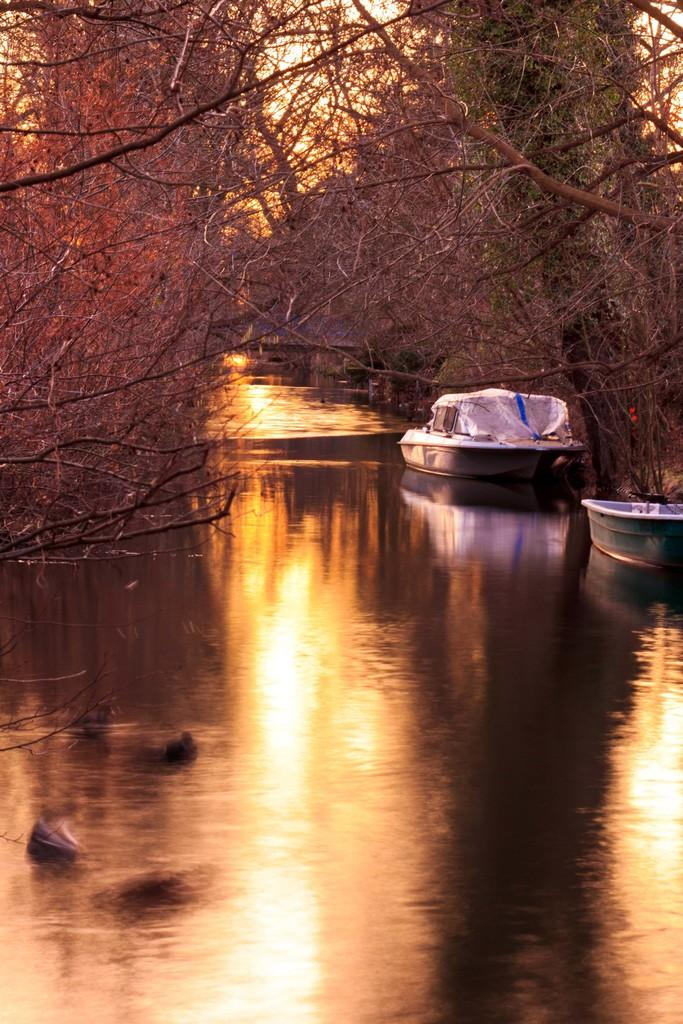What is the main feature of the image? The main feature of the image is water. Can you describe the water in the image? The water appears to be a river. Are there any objects or vehicles on the water? Yes, there are two boats on the water. What can be seen in the background of the image? There are trees visible in the background. What type of acoustics can be heard from the boats in the image? There is no information about the sound or acoustics of the boats in the image, so it cannot be determined. 